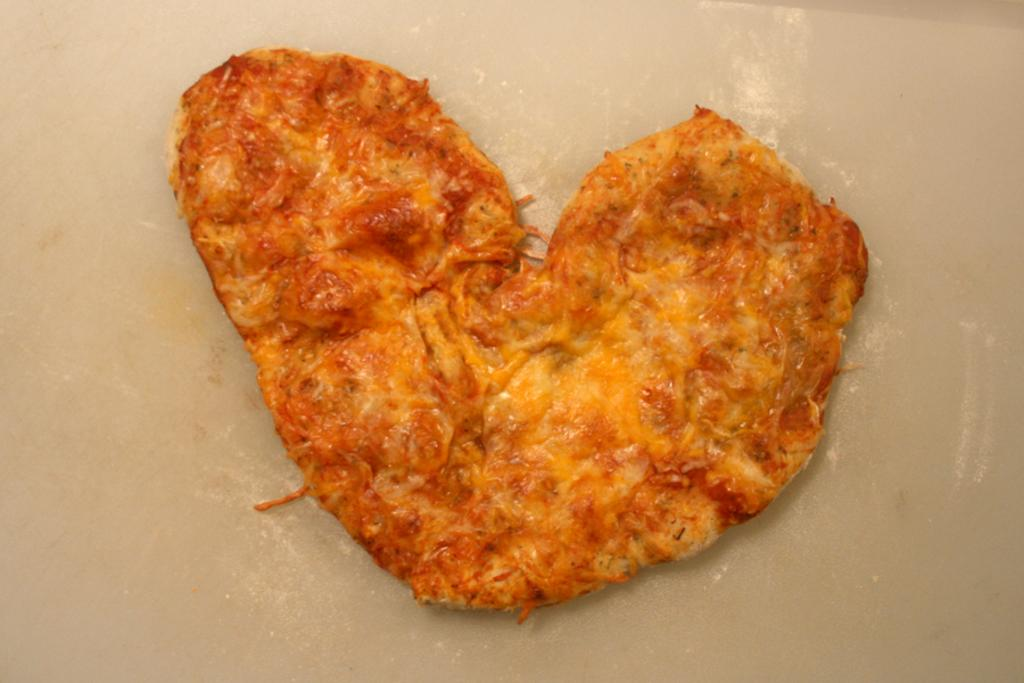What is the main subject of the image? There is a food item in the image. Can you describe the shape of the food item? The food item is in the shape of a heart. What is the noise level in the image? There is no information about noise level in the image, as it only features a food item in the shape of a heart. 